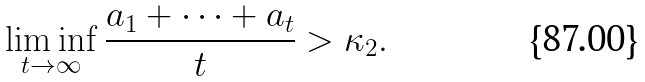<formula> <loc_0><loc_0><loc_500><loc_500>\liminf _ { t \to \infty } \frac { a _ { 1 } + \dots + a _ { t } } { t } > \kappa _ { 2 } .</formula> 